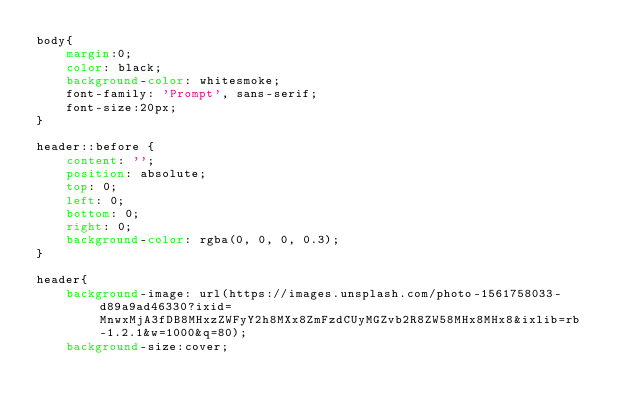Convert code to text. <code><loc_0><loc_0><loc_500><loc_500><_CSS_>body{
    margin:0;
    color: black;
    background-color: whitesmoke;
    font-family: 'Prompt', sans-serif;
    font-size:20px;
}

header::before {
    content: '';
    position: absolute;
    top: 0;
    left: 0;
    bottom: 0;
    right: 0;
    background-color: rgba(0, 0, 0, 0.3);
}

header{
    background-image: url(https://images.unsplash.com/photo-1561758033-d89a9ad46330?ixid=MnwxMjA3fDB8MHxzZWFyY2h8MXx8ZmFzdCUyMGZvb2R8ZW58MHx8MHx8&ixlib=rb-1.2.1&w=1000&q=80);
    background-size:cover;</code> 